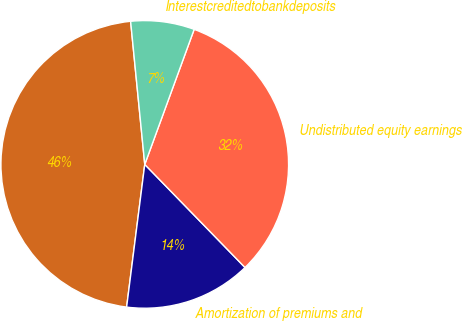Convert chart to OTSL. <chart><loc_0><loc_0><loc_500><loc_500><pie_chart><ecel><fcel>Amortization of premiums and<fcel>Undistributed equity earnings<fcel>Interestcreditedtobankdeposits<nl><fcel>46.42%<fcel>14.29%<fcel>32.14%<fcel>7.15%<nl></chart> 